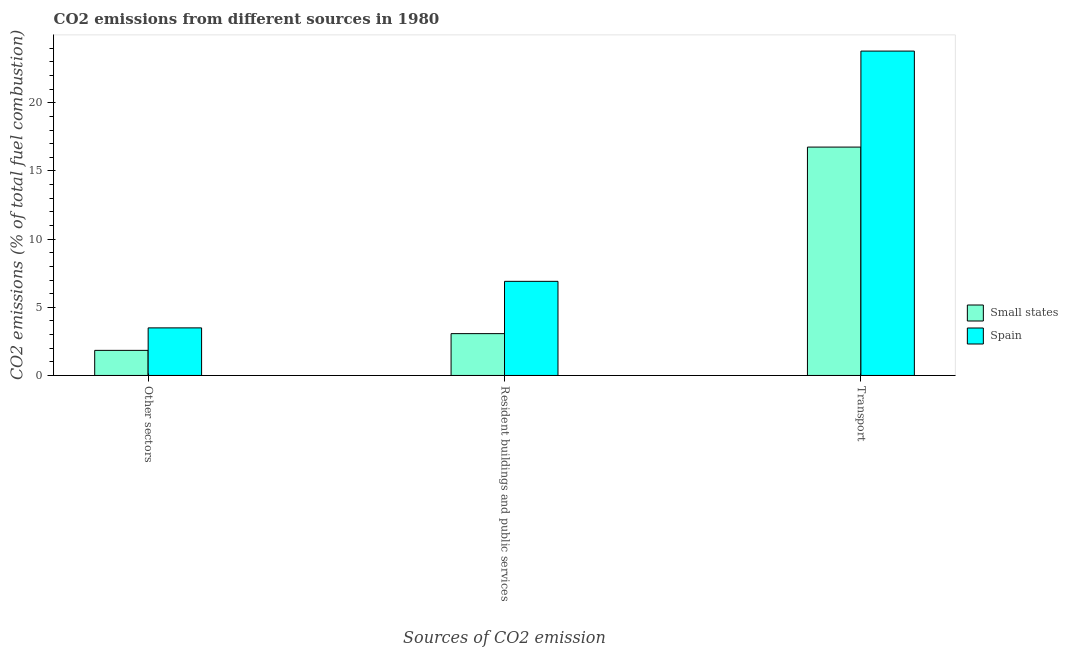How many different coloured bars are there?
Provide a succinct answer. 2. How many groups of bars are there?
Ensure brevity in your answer.  3. Are the number of bars on each tick of the X-axis equal?
Your response must be concise. Yes. What is the label of the 3rd group of bars from the left?
Provide a succinct answer. Transport. What is the percentage of co2 emissions from other sectors in Small states?
Ensure brevity in your answer.  1.84. Across all countries, what is the maximum percentage of co2 emissions from resident buildings and public services?
Your response must be concise. 6.9. Across all countries, what is the minimum percentage of co2 emissions from resident buildings and public services?
Keep it short and to the point. 3.07. In which country was the percentage of co2 emissions from transport maximum?
Ensure brevity in your answer.  Spain. In which country was the percentage of co2 emissions from resident buildings and public services minimum?
Your response must be concise. Small states. What is the total percentage of co2 emissions from resident buildings and public services in the graph?
Offer a very short reply. 9.97. What is the difference between the percentage of co2 emissions from resident buildings and public services in Spain and that in Small states?
Give a very brief answer. 3.84. What is the difference between the percentage of co2 emissions from transport in Spain and the percentage of co2 emissions from other sectors in Small states?
Ensure brevity in your answer.  21.95. What is the average percentage of co2 emissions from transport per country?
Offer a very short reply. 20.27. What is the difference between the percentage of co2 emissions from resident buildings and public services and percentage of co2 emissions from transport in Small states?
Your answer should be very brief. -13.68. In how many countries, is the percentage of co2 emissions from transport greater than 5 %?
Ensure brevity in your answer.  2. What is the ratio of the percentage of co2 emissions from other sectors in Spain to that in Small states?
Give a very brief answer. 1.9. Is the percentage of co2 emissions from resident buildings and public services in Spain less than that in Small states?
Offer a terse response. No. Is the difference between the percentage of co2 emissions from other sectors in Spain and Small states greater than the difference between the percentage of co2 emissions from resident buildings and public services in Spain and Small states?
Offer a very short reply. No. What is the difference between the highest and the second highest percentage of co2 emissions from transport?
Make the answer very short. 7.04. What is the difference between the highest and the lowest percentage of co2 emissions from other sectors?
Ensure brevity in your answer.  1.65. In how many countries, is the percentage of co2 emissions from other sectors greater than the average percentage of co2 emissions from other sectors taken over all countries?
Your answer should be compact. 1. What does the 2nd bar from the left in Other sectors represents?
Your response must be concise. Spain. What does the 1st bar from the right in Transport represents?
Your answer should be very brief. Spain. Is it the case that in every country, the sum of the percentage of co2 emissions from other sectors and percentage of co2 emissions from resident buildings and public services is greater than the percentage of co2 emissions from transport?
Provide a short and direct response. No. Are all the bars in the graph horizontal?
Make the answer very short. No. What is the difference between two consecutive major ticks on the Y-axis?
Ensure brevity in your answer.  5. Does the graph contain any zero values?
Offer a very short reply. No. Does the graph contain grids?
Your response must be concise. No. Where does the legend appear in the graph?
Make the answer very short. Center right. How are the legend labels stacked?
Ensure brevity in your answer.  Vertical. What is the title of the graph?
Your answer should be compact. CO2 emissions from different sources in 1980. What is the label or title of the X-axis?
Offer a very short reply. Sources of CO2 emission. What is the label or title of the Y-axis?
Your answer should be compact. CO2 emissions (% of total fuel combustion). What is the CO2 emissions (% of total fuel combustion) of Small states in Other sectors?
Offer a very short reply. 1.84. What is the CO2 emissions (% of total fuel combustion) of Spain in Other sectors?
Keep it short and to the point. 3.49. What is the CO2 emissions (% of total fuel combustion) in Small states in Resident buildings and public services?
Keep it short and to the point. 3.07. What is the CO2 emissions (% of total fuel combustion) of Spain in Resident buildings and public services?
Your response must be concise. 6.9. What is the CO2 emissions (% of total fuel combustion) of Small states in Transport?
Offer a very short reply. 16.75. What is the CO2 emissions (% of total fuel combustion) of Spain in Transport?
Offer a terse response. 23.79. Across all Sources of CO2 emission, what is the maximum CO2 emissions (% of total fuel combustion) in Small states?
Ensure brevity in your answer.  16.75. Across all Sources of CO2 emission, what is the maximum CO2 emissions (% of total fuel combustion) of Spain?
Give a very brief answer. 23.79. Across all Sources of CO2 emission, what is the minimum CO2 emissions (% of total fuel combustion) in Small states?
Your response must be concise. 1.84. Across all Sources of CO2 emission, what is the minimum CO2 emissions (% of total fuel combustion) of Spain?
Your answer should be very brief. 3.49. What is the total CO2 emissions (% of total fuel combustion) of Small states in the graph?
Offer a very short reply. 21.66. What is the total CO2 emissions (% of total fuel combustion) of Spain in the graph?
Give a very brief answer. 34.18. What is the difference between the CO2 emissions (% of total fuel combustion) of Small states in Other sectors and that in Resident buildings and public services?
Give a very brief answer. -1.23. What is the difference between the CO2 emissions (% of total fuel combustion) of Spain in Other sectors and that in Resident buildings and public services?
Provide a succinct answer. -3.41. What is the difference between the CO2 emissions (% of total fuel combustion) in Small states in Other sectors and that in Transport?
Offer a very short reply. -14.91. What is the difference between the CO2 emissions (% of total fuel combustion) of Spain in Other sectors and that in Transport?
Offer a terse response. -20.3. What is the difference between the CO2 emissions (% of total fuel combustion) of Small states in Resident buildings and public services and that in Transport?
Offer a very short reply. -13.68. What is the difference between the CO2 emissions (% of total fuel combustion) of Spain in Resident buildings and public services and that in Transport?
Your answer should be very brief. -16.89. What is the difference between the CO2 emissions (% of total fuel combustion) of Small states in Other sectors and the CO2 emissions (% of total fuel combustion) of Spain in Resident buildings and public services?
Your answer should be compact. -5.06. What is the difference between the CO2 emissions (% of total fuel combustion) in Small states in Other sectors and the CO2 emissions (% of total fuel combustion) in Spain in Transport?
Offer a very short reply. -21.95. What is the difference between the CO2 emissions (% of total fuel combustion) in Small states in Resident buildings and public services and the CO2 emissions (% of total fuel combustion) in Spain in Transport?
Make the answer very short. -20.72. What is the average CO2 emissions (% of total fuel combustion) in Small states per Sources of CO2 emission?
Provide a succinct answer. 7.22. What is the average CO2 emissions (% of total fuel combustion) of Spain per Sources of CO2 emission?
Ensure brevity in your answer.  11.39. What is the difference between the CO2 emissions (% of total fuel combustion) of Small states and CO2 emissions (% of total fuel combustion) of Spain in Other sectors?
Make the answer very short. -1.65. What is the difference between the CO2 emissions (% of total fuel combustion) in Small states and CO2 emissions (% of total fuel combustion) in Spain in Resident buildings and public services?
Offer a terse response. -3.84. What is the difference between the CO2 emissions (% of total fuel combustion) of Small states and CO2 emissions (% of total fuel combustion) of Spain in Transport?
Provide a short and direct response. -7.04. What is the ratio of the CO2 emissions (% of total fuel combustion) of Spain in Other sectors to that in Resident buildings and public services?
Keep it short and to the point. 0.51. What is the ratio of the CO2 emissions (% of total fuel combustion) of Small states in Other sectors to that in Transport?
Your answer should be very brief. 0.11. What is the ratio of the CO2 emissions (% of total fuel combustion) of Spain in Other sectors to that in Transport?
Your answer should be very brief. 0.15. What is the ratio of the CO2 emissions (% of total fuel combustion) of Small states in Resident buildings and public services to that in Transport?
Make the answer very short. 0.18. What is the ratio of the CO2 emissions (% of total fuel combustion) in Spain in Resident buildings and public services to that in Transport?
Offer a very short reply. 0.29. What is the difference between the highest and the second highest CO2 emissions (% of total fuel combustion) of Small states?
Ensure brevity in your answer.  13.68. What is the difference between the highest and the second highest CO2 emissions (% of total fuel combustion) in Spain?
Provide a succinct answer. 16.89. What is the difference between the highest and the lowest CO2 emissions (% of total fuel combustion) of Small states?
Offer a very short reply. 14.91. What is the difference between the highest and the lowest CO2 emissions (% of total fuel combustion) in Spain?
Offer a terse response. 20.3. 